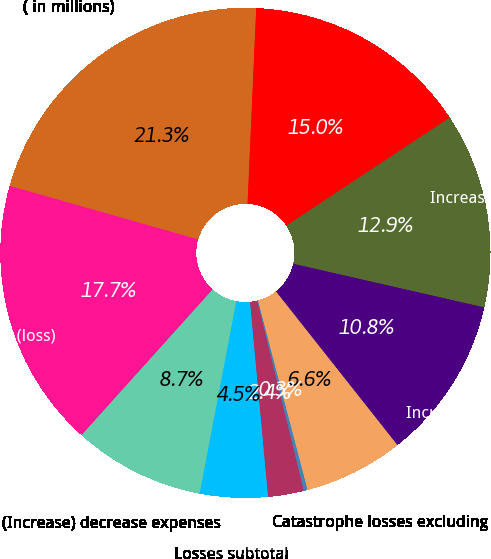Convert chart to OTSL. <chart><loc_0><loc_0><loc_500><loc_500><pie_chart><fcel>( in millions)<fcel>Underwriting income (loss) -<fcel>Increase (decrease) premiums<fcel>Incurred losses excluding<fcel>Catastrophe losses excluding<fcel>Catastrophe reserve<fcel>Non-catastrophe reserve<fcel>Losses subtotal<fcel>(Increase) decrease expenses<fcel>Underwriting income (loss)<nl><fcel>21.3%<fcel>14.99%<fcel>12.88%<fcel>10.78%<fcel>6.57%<fcel>0.25%<fcel>2.36%<fcel>4.46%<fcel>8.67%<fcel>17.74%<nl></chart> 